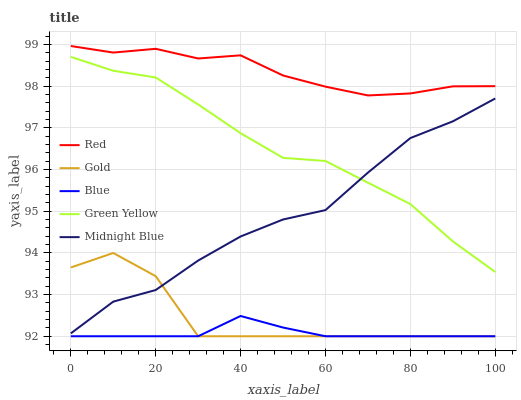Does Blue have the minimum area under the curve?
Answer yes or no. Yes. Does Red have the maximum area under the curve?
Answer yes or no. Yes. Does Green Yellow have the minimum area under the curve?
Answer yes or no. No. Does Green Yellow have the maximum area under the curve?
Answer yes or no. No. Is Blue the smoothest?
Answer yes or no. Yes. Is Gold the roughest?
Answer yes or no. Yes. Is Green Yellow the smoothest?
Answer yes or no. No. Is Green Yellow the roughest?
Answer yes or no. No. Does Blue have the lowest value?
Answer yes or no. Yes. Does Green Yellow have the lowest value?
Answer yes or no. No. Does Red have the highest value?
Answer yes or no. Yes. Does Green Yellow have the highest value?
Answer yes or no. No. Is Gold less than Green Yellow?
Answer yes or no. Yes. Is Green Yellow greater than Gold?
Answer yes or no. Yes. Does Midnight Blue intersect Gold?
Answer yes or no. Yes. Is Midnight Blue less than Gold?
Answer yes or no. No. Is Midnight Blue greater than Gold?
Answer yes or no. No. Does Gold intersect Green Yellow?
Answer yes or no. No. 